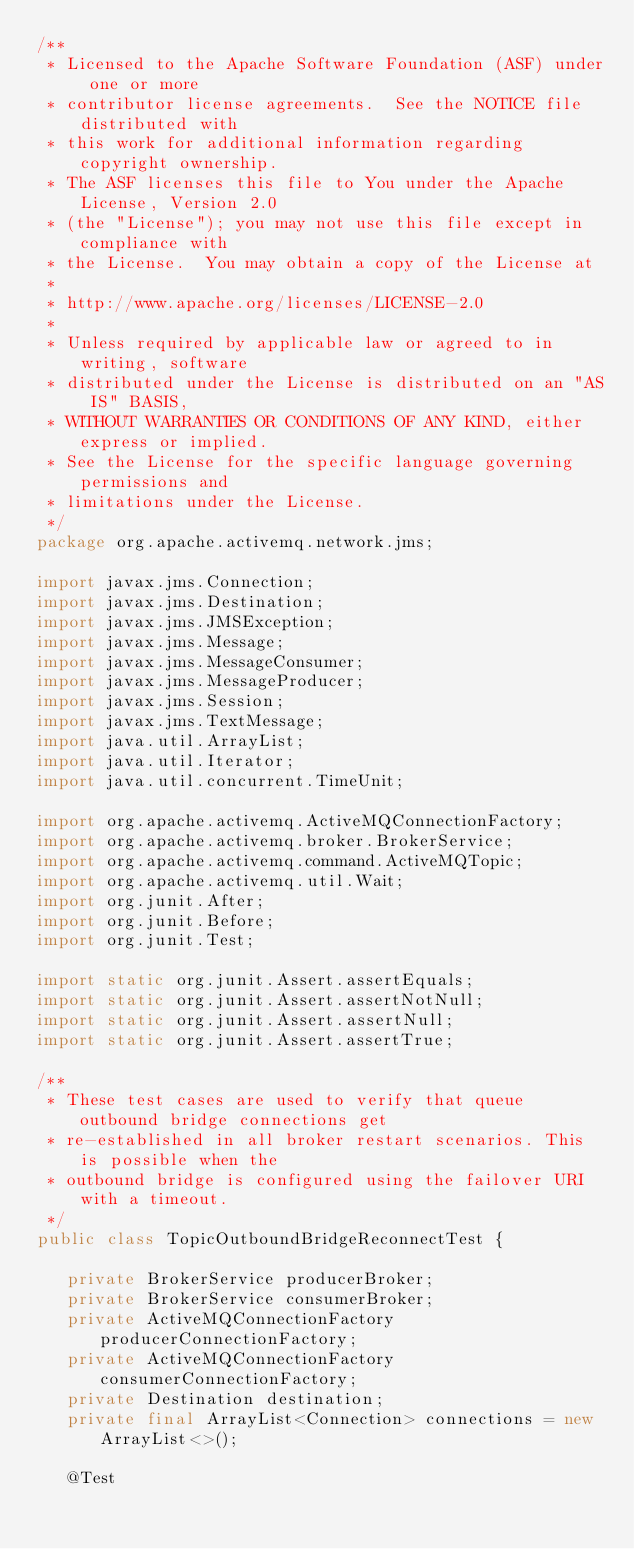<code> <loc_0><loc_0><loc_500><loc_500><_Java_>/**
 * Licensed to the Apache Software Foundation (ASF) under one or more
 * contributor license agreements.  See the NOTICE file distributed with
 * this work for additional information regarding copyright ownership.
 * The ASF licenses this file to You under the Apache License, Version 2.0
 * (the "License"); you may not use this file except in compliance with
 * the License.  You may obtain a copy of the License at
 *
 * http://www.apache.org/licenses/LICENSE-2.0
 *
 * Unless required by applicable law or agreed to in writing, software
 * distributed under the License is distributed on an "AS IS" BASIS,
 * WITHOUT WARRANTIES OR CONDITIONS OF ANY KIND, either express or implied.
 * See the License for the specific language governing permissions and
 * limitations under the License.
 */
package org.apache.activemq.network.jms;

import javax.jms.Connection;
import javax.jms.Destination;
import javax.jms.JMSException;
import javax.jms.Message;
import javax.jms.MessageConsumer;
import javax.jms.MessageProducer;
import javax.jms.Session;
import javax.jms.TextMessage;
import java.util.ArrayList;
import java.util.Iterator;
import java.util.concurrent.TimeUnit;

import org.apache.activemq.ActiveMQConnectionFactory;
import org.apache.activemq.broker.BrokerService;
import org.apache.activemq.command.ActiveMQTopic;
import org.apache.activemq.util.Wait;
import org.junit.After;
import org.junit.Before;
import org.junit.Test;

import static org.junit.Assert.assertEquals;
import static org.junit.Assert.assertNotNull;
import static org.junit.Assert.assertNull;
import static org.junit.Assert.assertTrue;

/**
 * These test cases are used to verify that queue outbound bridge connections get
 * re-established in all broker restart scenarios. This is possible when the
 * outbound bridge is configured using the failover URI with a timeout.
 */
public class TopicOutboundBridgeReconnectTest {

   private BrokerService producerBroker;
   private BrokerService consumerBroker;
   private ActiveMQConnectionFactory producerConnectionFactory;
   private ActiveMQConnectionFactory consumerConnectionFactory;
   private Destination destination;
   private final ArrayList<Connection> connections = new ArrayList<>();

   @Test</code> 